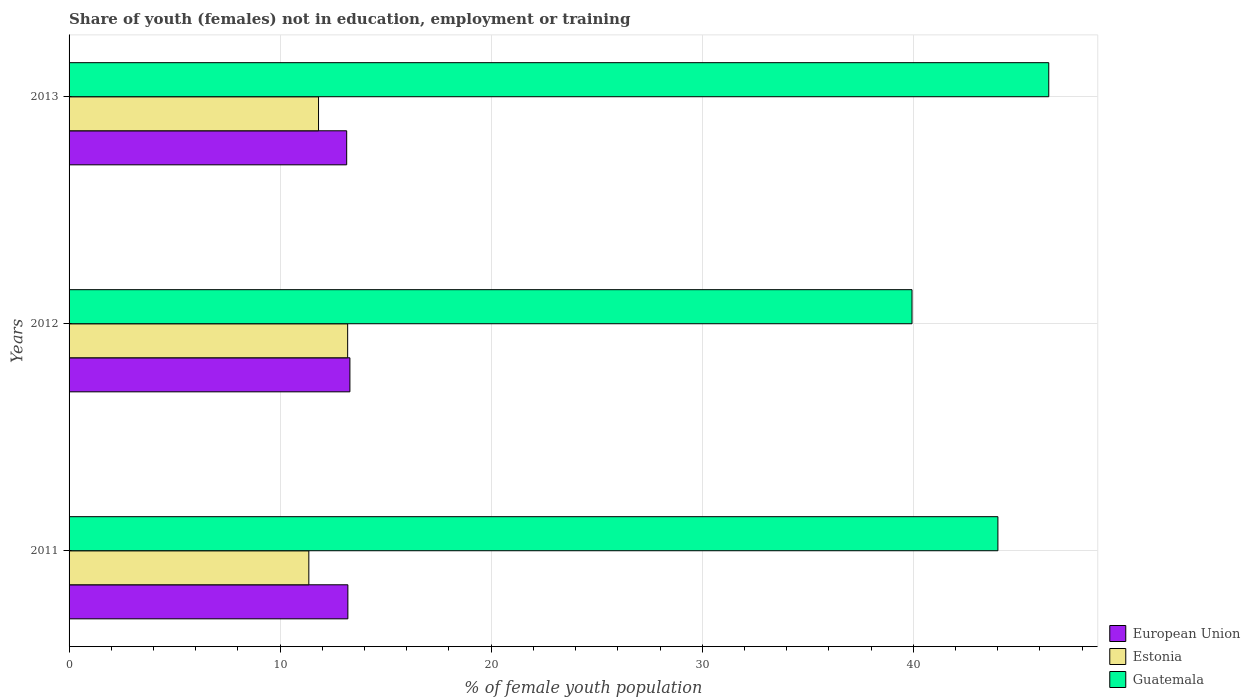Are the number of bars on each tick of the Y-axis equal?
Your answer should be compact. Yes. How many bars are there on the 3rd tick from the top?
Make the answer very short. 3. How many bars are there on the 1st tick from the bottom?
Keep it short and to the point. 3. In how many cases, is the number of bars for a given year not equal to the number of legend labels?
Keep it short and to the point. 0. What is the percentage of unemployed female population in in Estonia in 2013?
Make the answer very short. 11.82. Across all years, what is the maximum percentage of unemployed female population in in Guatemala?
Your answer should be very brief. 46.42. Across all years, what is the minimum percentage of unemployed female population in in European Union?
Keep it short and to the point. 13.15. What is the total percentage of unemployed female population in in Guatemala in the graph?
Provide a short and direct response. 130.37. What is the difference between the percentage of unemployed female population in in Estonia in 2012 and that in 2013?
Make the answer very short. 1.38. What is the difference between the percentage of unemployed female population in in Guatemala in 2013 and the percentage of unemployed female population in in European Union in 2012?
Make the answer very short. 33.11. What is the average percentage of unemployed female population in in European Union per year?
Provide a succinct answer. 13.22. In the year 2012, what is the difference between the percentage of unemployed female population in in Guatemala and percentage of unemployed female population in in Estonia?
Provide a succinct answer. 26.74. In how many years, is the percentage of unemployed female population in in European Union greater than 10 %?
Make the answer very short. 3. What is the ratio of the percentage of unemployed female population in in Guatemala in 2012 to that in 2013?
Offer a very short reply. 0.86. Is the percentage of unemployed female population in in European Union in 2011 less than that in 2013?
Your response must be concise. No. What is the difference between the highest and the second highest percentage of unemployed female population in in Guatemala?
Make the answer very short. 2.41. What is the difference between the highest and the lowest percentage of unemployed female population in in Estonia?
Ensure brevity in your answer.  1.84. In how many years, is the percentage of unemployed female population in in Guatemala greater than the average percentage of unemployed female population in in Guatemala taken over all years?
Offer a very short reply. 2. Is the sum of the percentage of unemployed female population in in Estonia in 2011 and 2013 greater than the maximum percentage of unemployed female population in in European Union across all years?
Provide a succinct answer. Yes. What does the 2nd bar from the top in 2013 represents?
Offer a very short reply. Estonia. Is it the case that in every year, the sum of the percentage of unemployed female population in in Estonia and percentage of unemployed female population in in European Union is greater than the percentage of unemployed female population in in Guatemala?
Your answer should be compact. No. How many years are there in the graph?
Provide a short and direct response. 3. Are the values on the major ticks of X-axis written in scientific E-notation?
Your answer should be compact. No. Does the graph contain any zero values?
Make the answer very short. No. How many legend labels are there?
Keep it short and to the point. 3. What is the title of the graph?
Your answer should be compact. Share of youth (females) not in education, employment or training. What is the label or title of the X-axis?
Provide a short and direct response. % of female youth population. What is the label or title of the Y-axis?
Make the answer very short. Years. What is the % of female youth population of European Union in 2011?
Your answer should be very brief. 13.21. What is the % of female youth population in Estonia in 2011?
Your response must be concise. 11.36. What is the % of female youth population in Guatemala in 2011?
Provide a succinct answer. 44.01. What is the % of female youth population of European Union in 2012?
Your answer should be compact. 13.31. What is the % of female youth population in Estonia in 2012?
Your answer should be compact. 13.2. What is the % of female youth population in Guatemala in 2012?
Your response must be concise. 39.94. What is the % of female youth population in European Union in 2013?
Your answer should be compact. 13.15. What is the % of female youth population in Estonia in 2013?
Your response must be concise. 11.82. What is the % of female youth population of Guatemala in 2013?
Offer a terse response. 46.42. Across all years, what is the maximum % of female youth population of European Union?
Ensure brevity in your answer.  13.31. Across all years, what is the maximum % of female youth population of Estonia?
Your response must be concise. 13.2. Across all years, what is the maximum % of female youth population in Guatemala?
Give a very brief answer. 46.42. Across all years, what is the minimum % of female youth population in European Union?
Your answer should be very brief. 13.15. Across all years, what is the minimum % of female youth population in Estonia?
Give a very brief answer. 11.36. Across all years, what is the minimum % of female youth population in Guatemala?
Give a very brief answer. 39.94. What is the total % of female youth population of European Union in the graph?
Offer a very short reply. 39.67. What is the total % of female youth population of Estonia in the graph?
Keep it short and to the point. 36.38. What is the total % of female youth population of Guatemala in the graph?
Offer a terse response. 130.37. What is the difference between the % of female youth population of European Union in 2011 and that in 2012?
Offer a very short reply. -0.1. What is the difference between the % of female youth population in Estonia in 2011 and that in 2012?
Ensure brevity in your answer.  -1.84. What is the difference between the % of female youth population in Guatemala in 2011 and that in 2012?
Your answer should be compact. 4.07. What is the difference between the % of female youth population in European Union in 2011 and that in 2013?
Keep it short and to the point. 0.06. What is the difference between the % of female youth population of Estonia in 2011 and that in 2013?
Your response must be concise. -0.46. What is the difference between the % of female youth population in Guatemala in 2011 and that in 2013?
Keep it short and to the point. -2.41. What is the difference between the % of female youth population of European Union in 2012 and that in 2013?
Ensure brevity in your answer.  0.15. What is the difference between the % of female youth population in Estonia in 2012 and that in 2013?
Keep it short and to the point. 1.38. What is the difference between the % of female youth population in Guatemala in 2012 and that in 2013?
Give a very brief answer. -6.48. What is the difference between the % of female youth population of European Union in 2011 and the % of female youth population of Estonia in 2012?
Offer a very short reply. 0.01. What is the difference between the % of female youth population of European Union in 2011 and the % of female youth population of Guatemala in 2012?
Offer a terse response. -26.73. What is the difference between the % of female youth population of Estonia in 2011 and the % of female youth population of Guatemala in 2012?
Offer a very short reply. -28.58. What is the difference between the % of female youth population of European Union in 2011 and the % of female youth population of Estonia in 2013?
Ensure brevity in your answer.  1.39. What is the difference between the % of female youth population in European Union in 2011 and the % of female youth population in Guatemala in 2013?
Ensure brevity in your answer.  -33.21. What is the difference between the % of female youth population in Estonia in 2011 and the % of female youth population in Guatemala in 2013?
Offer a terse response. -35.06. What is the difference between the % of female youth population in European Union in 2012 and the % of female youth population in Estonia in 2013?
Make the answer very short. 1.49. What is the difference between the % of female youth population in European Union in 2012 and the % of female youth population in Guatemala in 2013?
Provide a short and direct response. -33.11. What is the difference between the % of female youth population of Estonia in 2012 and the % of female youth population of Guatemala in 2013?
Your answer should be compact. -33.22. What is the average % of female youth population in European Union per year?
Provide a succinct answer. 13.22. What is the average % of female youth population in Estonia per year?
Your response must be concise. 12.13. What is the average % of female youth population of Guatemala per year?
Keep it short and to the point. 43.46. In the year 2011, what is the difference between the % of female youth population of European Union and % of female youth population of Estonia?
Give a very brief answer. 1.85. In the year 2011, what is the difference between the % of female youth population of European Union and % of female youth population of Guatemala?
Make the answer very short. -30.8. In the year 2011, what is the difference between the % of female youth population in Estonia and % of female youth population in Guatemala?
Your response must be concise. -32.65. In the year 2012, what is the difference between the % of female youth population of European Union and % of female youth population of Estonia?
Provide a short and direct response. 0.11. In the year 2012, what is the difference between the % of female youth population of European Union and % of female youth population of Guatemala?
Provide a short and direct response. -26.63. In the year 2012, what is the difference between the % of female youth population of Estonia and % of female youth population of Guatemala?
Make the answer very short. -26.74. In the year 2013, what is the difference between the % of female youth population of European Union and % of female youth population of Estonia?
Give a very brief answer. 1.33. In the year 2013, what is the difference between the % of female youth population in European Union and % of female youth population in Guatemala?
Your response must be concise. -33.27. In the year 2013, what is the difference between the % of female youth population of Estonia and % of female youth population of Guatemala?
Your response must be concise. -34.6. What is the ratio of the % of female youth population in European Union in 2011 to that in 2012?
Offer a terse response. 0.99. What is the ratio of the % of female youth population in Estonia in 2011 to that in 2012?
Ensure brevity in your answer.  0.86. What is the ratio of the % of female youth population of Guatemala in 2011 to that in 2012?
Make the answer very short. 1.1. What is the ratio of the % of female youth population in European Union in 2011 to that in 2013?
Make the answer very short. 1. What is the ratio of the % of female youth population in Estonia in 2011 to that in 2013?
Give a very brief answer. 0.96. What is the ratio of the % of female youth population in Guatemala in 2011 to that in 2013?
Your answer should be very brief. 0.95. What is the ratio of the % of female youth population of European Union in 2012 to that in 2013?
Make the answer very short. 1.01. What is the ratio of the % of female youth population of Estonia in 2012 to that in 2013?
Your response must be concise. 1.12. What is the ratio of the % of female youth population in Guatemala in 2012 to that in 2013?
Keep it short and to the point. 0.86. What is the difference between the highest and the second highest % of female youth population of European Union?
Your answer should be very brief. 0.1. What is the difference between the highest and the second highest % of female youth population of Estonia?
Your answer should be very brief. 1.38. What is the difference between the highest and the second highest % of female youth population of Guatemala?
Offer a terse response. 2.41. What is the difference between the highest and the lowest % of female youth population of European Union?
Offer a very short reply. 0.15. What is the difference between the highest and the lowest % of female youth population of Estonia?
Offer a terse response. 1.84. What is the difference between the highest and the lowest % of female youth population in Guatemala?
Your response must be concise. 6.48. 